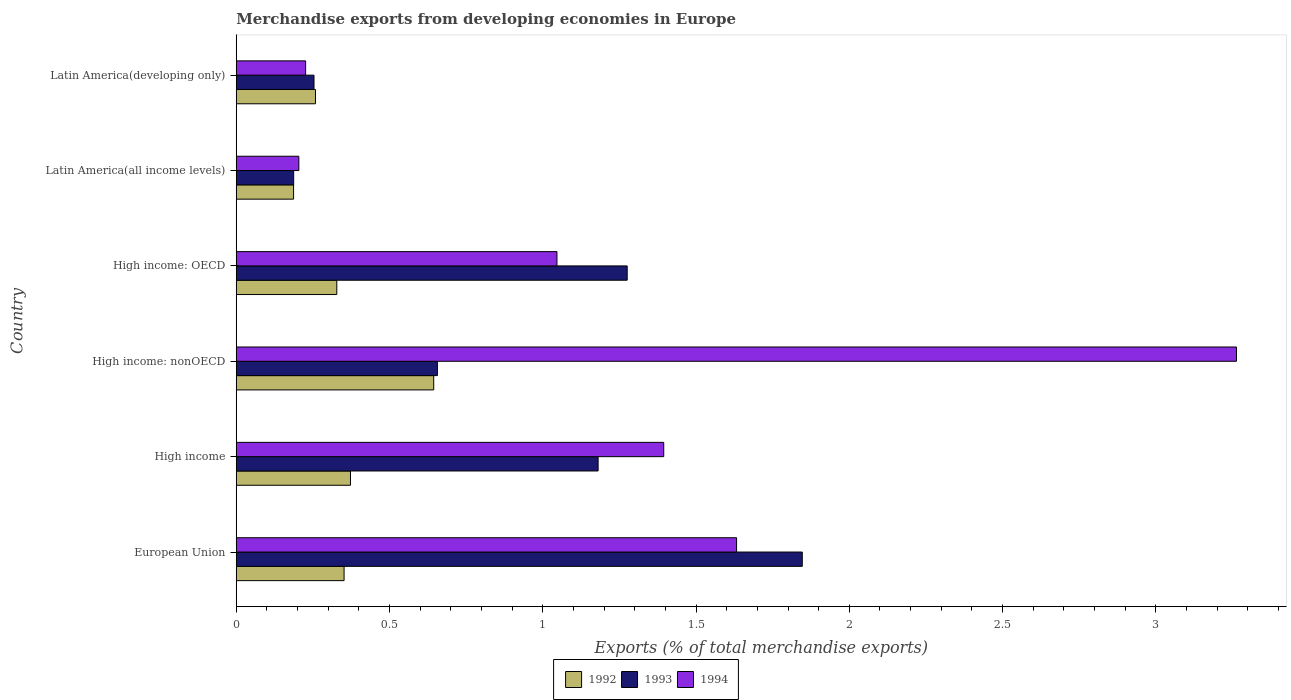How many different coloured bars are there?
Make the answer very short. 3. Are the number of bars per tick equal to the number of legend labels?
Offer a very short reply. Yes. How many bars are there on the 3rd tick from the bottom?
Ensure brevity in your answer.  3. What is the label of the 1st group of bars from the top?
Provide a short and direct response. Latin America(developing only). In how many cases, is the number of bars for a given country not equal to the number of legend labels?
Your answer should be compact. 0. What is the percentage of total merchandise exports in 1993 in High income: nonOECD?
Provide a succinct answer. 0.66. Across all countries, what is the maximum percentage of total merchandise exports in 1993?
Your answer should be compact. 1.85. Across all countries, what is the minimum percentage of total merchandise exports in 1994?
Your answer should be compact. 0.2. In which country was the percentage of total merchandise exports in 1994 maximum?
Ensure brevity in your answer.  High income: nonOECD. In which country was the percentage of total merchandise exports in 1993 minimum?
Your answer should be very brief. Latin America(all income levels). What is the total percentage of total merchandise exports in 1993 in the graph?
Offer a terse response. 5.4. What is the difference between the percentage of total merchandise exports in 1994 in High income: nonOECD and that in Latin America(developing only)?
Give a very brief answer. 3.04. What is the difference between the percentage of total merchandise exports in 1993 in European Union and the percentage of total merchandise exports in 1992 in Latin America(developing only)?
Ensure brevity in your answer.  1.59. What is the average percentage of total merchandise exports in 1994 per country?
Give a very brief answer. 1.29. What is the difference between the percentage of total merchandise exports in 1992 and percentage of total merchandise exports in 1993 in Latin America(all income levels)?
Offer a very short reply. -0. In how many countries, is the percentage of total merchandise exports in 1994 greater than 1.7 %?
Make the answer very short. 1. What is the ratio of the percentage of total merchandise exports in 1992 in European Union to that in Latin America(developing only)?
Your answer should be very brief. 1.36. Is the percentage of total merchandise exports in 1992 in High income: nonOECD less than that in Latin America(developing only)?
Offer a terse response. No. Is the difference between the percentage of total merchandise exports in 1992 in Latin America(all income levels) and Latin America(developing only) greater than the difference between the percentage of total merchandise exports in 1993 in Latin America(all income levels) and Latin America(developing only)?
Keep it short and to the point. No. What is the difference between the highest and the second highest percentage of total merchandise exports in 1992?
Your answer should be compact. 0.27. What is the difference between the highest and the lowest percentage of total merchandise exports in 1993?
Your response must be concise. 1.66. What does the 3rd bar from the top in High income represents?
Your answer should be very brief. 1992. What does the 3rd bar from the bottom in High income represents?
Your answer should be very brief. 1994. How many bars are there?
Offer a very short reply. 18. Are all the bars in the graph horizontal?
Keep it short and to the point. Yes. How many countries are there in the graph?
Your answer should be compact. 6. What is the difference between two consecutive major ticks on the X-axis?
Provide a short and direct response. 0.5. Does the graph contain any zero values?
Offer a terse response. No. How many legend labels are there?
Offer a very short reply. 3. How are the legend labels stacked?
Give a very brief answer. Horizontal. What is the title of the graph?
Your answer should be compact. Merchandise exports from developing economies in Europe. What is the label or title of the X-axis?
Provide a succinct answer. Exports (% of total merchandise exports). What is the label or title of the Y-axis?
Ensure brevity in your answer.  Country. What is the Exports (% of total merchandise exports) of 1992 in European Union?
Provide a short and direct response. 0.35. What is the Exports (% of total merchandise exports) in 1993 in European Union?
Your answer should be very brief. 1.85. What is the Exports (% of total merchandise exports) of 1994 in European Union?
Provide a succinct answer. 1.63. What is the Exports (% of total merchandise exports) of 1992 in High income?
Your answer should be very brief. 0.37. What is the Exports (% of total merchandise exports) of 1993 in High income?
Provide a short and direct response. 1.18. What is the Exports (% of total merchandise exports) of 1994 in High income?
Your answer should be very brief. 1.39. What is the Exports (% of total merchandise exports) of 1992 in High income: nonOECD?
Your answer should be very brief. 0.64. What is the Exports (% of total merchandise exports) of 1993 in High income: nonOECD?
Provide a succinct answer. 0.66. What is the Exports (% of total merchandise exports) in 1994 in High income: nonOECD?
Ensure brevity in your answer.  3.26. What is the Exports (% of total merchandise exports) in 1992 in High income: OECD?
Give a very brief answer. 0.33. What is the Exports (% of total merchandise exports) in 1993 in High income: OECD?
Keep it short and to the point. 1.28. What is the Exports (% of total merchandise exports) of 1994 in High income: OECD?
Offer a very short reply. 1.05. What is the Exports (% of total merchandise exports) of 1992 in Latin America(all income levels)?
Provide a short and direct response. 0.19. What is the Exports (% of total merchandise exports) of 1993 in Latin America(all income levels)?
Your response must be concise. 0.19. What is the Exports (% of total merchandise exports) in 1994 in Latin America(all income levels)?
Offer a terse response. 0.2. What is the Exports (% of total merchandise exports) of 1992 in Latin America(developing only)?
Your answer should be very brief. 0.26. What is the Exports (% of total merchandise exports) in 1993 in Latin America(developing only)?
Keep it short and to the point. 0.25. What is the Exports (% of total merchandise exports) of 1994 in Latin America(developing only)?
Provide a short and direct response. 0.23. Across all countries, what is the maximum Exports (% of total merchandise exports) in 1992?
Offer a terse response. 0.64. Across all countries, what is the maximum Exports (% of total merchandise exports) in 1993?
Offer a terse response. 1.85. Across all countries, what is the maximum Exports (% of total merchandise exports) in 1994?
Keep it short and to the point. 3.26. Across all countries, what is the minimum Exports (% of total merchandise exports) of 1992?
Provide a succinct answer. 0.19. Across all countries, what is the minimum Exports (% of total merchandise exports) in 1993?
Ensure brevity in your answer.  0.19. Across all countries, what is the minimum Exports (% of total merchandise exports) in 1994?
Make the answer very short. 0.2. What is the total Exports (% of total merchandise exports) of 1992 in the graph?
Your response must be concise. 2.14. What is the total Exports (% of total merchandise exports) in 1993 in the graph?
Give a very brief answer. 5.4. What is the total Exports (% of total merchandise exports) in 1994 in the graph?
Keep it short and to the point. 7.77. What is the difference between the Exports (% of total merchandise exports) in 1992 in European Union and that in High income?
Your answer should be compact. -0.02. What is the difference between the Exports (% of total merchandise exports) in 1993 in European Union and that in High income?
Your answer should be very brief. 0.67. What is the difference between the Exports (% of total merchandise exports) in 1994 in European Union and that in High income?
Keep it short and to the point. 0.24. What is the difference between the Exports (% of total merchandise exports) in 1992 in European Union and that in High income: nonOECD?
Your response must be concise. -0.29. What is the difference between the Exports (% of total merchandise exports) of 1993 in European Union and that in High income: nonOECD?
Offer a very short reply. 1.19. What is the difference between the Exports (% of total merchandise exports) of 1994 in European Union and that in High income: nonOECD?
Provide a succinct answer. -1.63. What is the difference between the Exports (% of total merchandise exports) of 1992 in European Union and that in High income: OECD?
Provide a succinct answer. 0.02. What is the difference between the Exports (% of total merchandise exports) in 1993 in European Union and that in High income: OECD?
Keep it short and to the point. 0.57. What is the difference between the Exports (% of total merchandise exports) of 1994 in European Union and that in High income: OECD?
Keep it short and to the point. 0.59. What is the difference between the Exports (% of total merchandise exports) in 1992 in European Union and that in Latin America(all income levels)?
Provide a short and direct response. 0.16. What is the difference between the Exports (% of total merchandise exports) in 1993 in European Union and that in Latin America(all income levels)?
Provide a short and direct response. 1.66. What is the difference between the Exports (% of total merchandise exports) in 1994 in European Union and that in Latin America(all income levels)?
Your answer should be compact. 1.43. What is the difference between the Exports (% of total merchandise exports) of 1992 in European Union and that in Latin America(developing only)?
Offer a very short reply. 0.09. What is the difference between the Exports (% of total merchandise exports) in 1993 in European Union and that in Latin America(developing only)?
Your answer should be very brief. 1.59. What is the difference between the Exports (% of total merchandise exports) in 1994 in European Union and that in Latin America(developing only)?
Give a very brief answer. 1.41. What is the difference between the Exports (% of total merchandise exports) in 1992 in High income and that in High income: nonOECD?
Provide a succinct answer. -0.27. What is the difference between the Exports (% of total merchandise exports) of 1993 in High income and that in High income: nonOECD?
Provide a short and direct response. 0.52. What is the difference between the Exports (% of total merchandise exports) in 1994 in High income and that in High income: nonOECD?
Offer a very short reply. -1.87. What is the difference between the Exports (% of total merchandise exports) in 1992 in High income and that in High income: OECD?
Offer a terse response. 0.04. What is the difference between the Exports (% of total merchandise exports) of 1993 in High income and that in High income: OECD?
Provide a short and direct response. -0.09. What is the difference between the Exports (% of total merchandise exports) of 1994 in High income and that in High income: OECD?
Your answer should be compact. 0.35. What is the difference between the Exports (% of total merchandise exports) in 1992 in High income and that in Latin America(all income levels)?
Offer a very short reply. 0.19. What is the difference between the Exports (% of total merchandise exports) of 1994 in High income and that in Latin America(all income levels)?
Give a very brief answer. 1.19. What is the difference between the Exports (% of total merchandise exports) of 1992 in High income and that in Latin America(developing only)?
Keep it short and to the point. 0.11. What is the difference between the Exports (% of total merchandise exports) in 1993 in High income and that in Latin America(developing only)?
Ensure brevity in your answer.  0.93. What is the difference between the Exports (% of total merchandise exports) in 1994 in High income and that in Latin America(developing only)?
Give a very brief answer. 1.17. What is the difference between the Exports (% of total merchandise exports) of 1992 in High income: nonOECD and that in High income: OECD?
Give a very brief answer. 0.32. What is the difference between the Exports (% of total merchandise exports) in 1993 in High income: nonOECD and that in High income: OECD?
Make the answer very short. -0.62. What is the difference between the Exports (% of total merchandise exports) in 1994 in High income: nonOECD and that in High income: OECD?
Offer a terse response. 2.22. What is the difference between the Exports (% of total merchandise exports) of 1992 in High income: nonOECD and that in Latin America(all income levels)?
Offer a very short reply. 0.46. What is the difference between the Exports (% of total merchandise exports) in 1993 in High income: nonOECD and that in Latin America(all income levels)?
Your response must be concise. 0.47. What is the difference between the Exports (% of total merchandise exports) of 1994 in High income: nonOECD and that in Latin America(all income levels)?
Provide a succinct answer. 3.06. What is the difference between the Exports (% of total merchandise exports) of 1992 in High income: nonOECD and that in Latin America(developing only)?
Give a very brief answer. 0.39. What is the difference between the Exports (% of total merchandise exports) in 1993 in High income: nonOECD and that in Latin America(developing only)?
Provide a short and direct response. 0.4. What is the difference between the Exports (% of total merchandise exports) of 1994 in High income: nonOECD and that in Latin America(developing only)?
Your response must be concise. 3.04. What is the difference between the Exports (% of total merchandise exports) of 1992 in High income: OECD and that in Latin America(all income levels)?
Provide a succinct answer. 0.14. What is the difference between the Exports (% of total merchandise exports) of 1993 in High income: OECD and that in Latin America(all income levels)?
Give a very brief answer. 1.09. What is the difference between the Exports (% of total merchandise exports) of 1994 in High income: OECD and that in Latin America(all income levels)?
Make the answer very short. 0.84. What is the difference between the Exports (% of total merchandise exports) of 1992 in High income: OECD and that in Latin America(developing only)?
Offer a terse response. 0.07. What is the difference between the Exports (% of total merchandise exports) in 1993 in High income: OECD and that in Latin America(developing only)?
Your answer should be compact. 1.02. What is the difference between the Exports (% of total merchandise exports) in 1994 in High income: OECD and that in Latin America(developing only)?
Make the answer very short. 0.82. What is the difference between the Exports (% of total merchandise exports) in 1992 in Latin America(all income levels) and that in Latin America(developing only)?
Offer a very short reply. -0.07. What is the difference between the Exports (% of total merchandise exports) in 1993 in Latin America(all income levels) and that in Latin America(developing only)?
Keep it short and to the point. -0.07. What is the difference between the Exports (% of total merchandise exports) in 1994 in Latin America(all income levels) and that in Latin America(developing only)?
Ensure brevity in your answer.  -0.02. What is the difference between the Exports (% of total merchandise exports) in 1992 in European Union and the Exports (% of total merchandise exports) in 1993 in High income?
Make the answer very short. -0.83. What is the difference between the Exports (% of total merchandise exports) in 1992 in European Union and the Exports (% of total merchandise exports) in 1994 in High income?
Provide a short and direct response. -1.04. What is the difference between the Exports (% of total merchandise exports) of 1993 in European Union and the Exports (% of total merchandise exports) of 1994 in High income?
Your answer should be compact. 0.45. What is the difference between the Exports (% of total merchandise exports) of 1992 in European Union and the Exports (% of total merchandise exports) of 1993 in High income: nonOECD?
Your answer should be compact. -0.3. What is the difference between the Exports (% of total merchandise exports) of 1992 in European Union and the Exports (% of total merchandise exports) of 1994 in High income: nonOECD?
Ensure brevity in your answer.  -2.91. What is the difference between the Exports (% of total merchandise exports) of 1993 in European Union and the Exports (% of total merchandise exports) of 1994 in High income: nonOECD?
Provide a short and direct response. -1.42. What is the difference between the Exports (% of total merchandise exports) in 1992 in European Union and the Exports (% of total merchandise exports) in 1993 in High income: OECD?
Your response must be concise. -0.92. What is the difference between the Exports (% of total merchandise exports) in 1992 in European Union and the Exports (% of total merchandise exports) in 1994 in High income: OECD?
Your response must be concise. -0.69. What is the difference between the Exports (% of total merchandise exports) of 1993 in European Union and the Exports (% of total merchandise exports) of 1994 in High income: OECD?
Give a very brief answer. 0.8. What is the difference between the Exports (% of total merchandise exports) of 1992 in European Union and the Exports (% of total merchandise exports) of 1993 in Latin America(all income levels)?
Your answer should be very brief. 0.16. What is the difference between the Exports (% of total merchandise exports) in 1992 in European Union and the Exports (% of total merchandise exports) in 1994 in Latin America(all income levels)?
Your answer should be compact. 0.15. What is the difference between the Exports (% of total merchandise exports) of 1993 in European Union and the Exports (% of total merchandise exports) of 1994 in Latin America(all income levels)?
Offer a very short reply. 1.64. What is the difference between the Exports (% of total merchandise exports) of 1992 in European Union and the Exports (% of total merchandise exports) of 1993 in Latin America(developing only)?
Keep it short and to the point. 0.1. What is the difference between the Exports (% of total merchandise exports) in 1992 in European Union and the Exports (% of total merchandise exports) in 1994 in Latin America(developing only)?
Provide a short and direct response. 0.13. What is the difference between the Exports (% of total merchandise exports) in 1993 in European Union and the Exports (% of total merchandise exports) in 1994 in Latin America(developing only)?
Ensure brevity in your answer.  1.62. What is the difference between the Exports (% of total merchandise exports) of 1992 in High income and the Exports (% of total merchandise exports) of 1993 in High income: nonOECD?
Keep it short and to the point. -0.28. What is the difference between the Exports (% of total merchandise exports) in 1992 in High income and the Exports (% of total merchandise exports) in 1994 in High income: nonOECD?
Make the answer very short. -2.89. What is the difference between the Exports (% of total merchandise exports) in 1993 in High income and the Exports (% of total merchandise exports) in 1994 in High income: nonOECD?
Give a very brief answer. -2.08. What is the difference between the Exports (% of total merchandise exports) in 1992 in High income and the Exports (% of total merchandise exports) in 1993 in High income: OECD?
Your answer should be compact. -0.9. What is the difference between the Exports (% of total merchandise exports) of 1992 in High income and the Exports (% of total merchandise exports) of 1994 in High income: OECD?
Provide a succinct answer. -0.67. What is the difference between the Exports (% of total merchandise exports) of 1993 in High income and the Exports (% of total merchandise exports) of 1994 in High income: OECD?
Make the answer very short. 0.13. What is the difference between the Exports (% of total merchandise exports) of 1992 in High income and the Exports (% of total merchandise exports) of 1993 in Latin America(all income levels)?
Your answer should be compact. 0.19. What is the difference between the Exports (% of total merchandise exports) in 1992 in High income and the Exports (% of total merchandise exports) in 1994 in Latin America(all income levels)?
Offer a very short reply. 0.17. What is the difference between the Exports (% of total merchandise exports) of 1993 in High income and the Exports (% of total merchandise exports) of 1994 in Latin America(all income levels)?
Your response must be concise. 0.98. What is the difference between the Exports (% of total merchandise exports) in 1992 in High income and the Exports (% of total merchandise exports) in 1993 in Latin America(developing only)?
Your response must be concise. 0.12. What is the difference between the Exports (% of total merchandise exports) in 1992 in High income and the Exports (% of total merchandise exports) in 1994 in Latin America(developing only)?
Your answer should be compact. 0.15. What is the difference between the Exports (% of total merchandise exports) in 1993 in High income and the Exports (% of total merchandise exports) in 1994 in Latin America(developing only)?
Make the answer very short. 0.95. What is the difference between the Exports (% of total merchandise exports) in 1992 in High income: nonOECD and the Exports (% of total merchandise exports) in 1993 in High income: OECD?
Offer a terse response. -0.63. What is the difference between the Exports (% of total merchandise exports) in 1992 in High income: nonOECD and the Exports (% of total merchandise exports) in 1994 in High income: OECD?
Provide a short and direct response. -0.4. What is the difference between the Exports (% of total merchandise exports) of 1993 in High income: nonOECD and the Exports (% of total merchandise exports) of 1994 in High income: OECD?
Your answer should be compact. -0.39. What is the difference between the Exports (% of total merchandise exports) in 1992 in High income: nonOECD and the Exports (% of total merchandise exports) in 1993 in Latin America(all income levels)?
Provide a succinct answer. 0.46. What is the difference between the Exports (% of total merchandise exports) of 1992 in High income: nonOECD and the Exports (% of total merchandise exports) of 1994 in Latin America(all income levels)?
Your answer should be very brief. 0.44. What is the difference between the Exports (% of total merchandise exports) of 1993 in High income: nonOECD and the Exports (% of total merchandise exports) of 1994 in Latin America(all income levels)?
Provide a succinct answer. 0.45. What is the difference between the Exports (% of total merchandise exports) of 1992 in High income: nonOECD and the Exports (% of total merchandise exports) of 1993 in Latin America(developing only)?
Keep it short and to the point. 0.39. What is the difference between the Exports (% of total merchandise exports) in 1992 in High income: nonOECD and the Exports (% of total merchandise exports) in 1994 in Latin America(developing only)?
Your answer should be very brief. 0.42. What is the difference between the Exports (% of total merchandise exports) of 1993 in High income: nonOECD and the Exports (% of total merchandise exports) of 1994 in Latin America(developing only)?
Your answer should be compact. 0.43. What is the difference between the Exports (% of total merchandise exports) in 1992 in High income: OECD and the Exports (% of total merchandise exports) in 1993 in Latin America(all income levels)?
Keep it short and to the point. 0.14. What is the difference between the Exports (% of total merchandise exports) of 1992 in High income: OECD and the Exports (% of total merchandise exports) of 1994 in Latin America(all income levels)?
Make the answer very short. 0.12. What is the difference between the Exports (% of total merchandise exports) of 1993 in High income: OECD and the Exports (% of total merchandise exports) of 1994 in Latin America(all income levels)?
Offer a terse response. 1.07. What is the difference between the Exports (% of total merchandise exports) of 1992 in High income: OECD and the Exports (% of total merchandise exports) of 1993 in Latin America(developing only)?
Provide a succinct answer. 0.07. What is the difference between the Exports (% of total merchandise exports) in 1992 in High income: OECD and the Exports (% of total merchandise exports) in 1994 in Latin America(developing only)?
Keep it short and to the point. 0.1. What is the difference between the Exports (% of total merchandise exports) of 1993 in High income: OECD and the Exports (% of total merchandise exports) of 1994 in Latin America(developing only)?
Offer a very short reply. 1.05. What is the difference between the Exports (% of total merchandise exports) of 1992 in Latin America(all income levels) and the Exports (% of total merchandise exports) of 1993 in Latin America(developing only)?
Ensure brevity in your answer.  -0.07. What is the difference between the Exports (% of total merchandise exports) of 1992 in Latin America(all income levels) and the Exports (% of total merchandise exports) of 1994 in Latin America(developing only)?
Ensure brevity in your answer.  -0.04. What is the difference between the Exports (% of total merchandise exports) in 1993 in Latin America(all income levels) and the Exports (% of total merchandise exports) in 1994 in Latin America(developing only)?
Your answer should be very brief. -0.04. What is the average Exports (% of total merchandise exports) in 1992 per country?
Ensure brevity in your answer.  0.36. What is the average Exports (% of total merchandise exports) of 1993 per country?
Your answer should be very brief. 0.9. What is the average Exports (% of total merchandise exports) of 1994 per country?
Your response must be concise. 1.29. What is the difference between the Exports (% of total merchandise exports) of 1992 and Exports (% of total merchandise exports) of 1993 in European Union?
Your response must be concise. -1.49. What is the difference between the Exports (% of total merchandise exports) of 1992 and Exports (% of total merchandise exports) of 1994 in European Union?
Keep it short and to the point. -1.28. What is the difference between the Exports (% of total merchandise exports) of 1993 and Exports (% of total merchandise exports) of 1994 in European Union?
Your response must be concise. 0.21. What is the difference between the Exports (% of total merchandise exports) of 1992 and Exports (% of total merchandise exports) of 1993 in High income?
Offer a terse response. -0.81. What is the difference between the Exports (% of total merchandise exports) of 1992 and Exports (% of total merchandise exports) of 1994 in High income?
Make the answer very short. -1.02. What is the difference between the Exports (% of total merchandise exports) of 1993 and Exports (% of total merchandise exports) of 1994 in High income?
Provide a short and direct response. -0.21. What is the difference between the Exports (% of total merchandise exports) in 1992 and Exports (% of total merchandise exports) in 1993 in High income: nonOECD?
Offer a terse response. -0.01. What is the difference between the Exports (% of total merchandise exports) in 1992 and Exports (% of total merchandise exports) in 1994 in High income: nonOECD?
Ensure brevity in your answer.  -2.62. What is the difference between the Exports (% of total merchandise exports) of 1993 and Exports (% of total merchandise exports) of 1994 in High income: nonOECD?
Offer a terse response. -2.61. What is the difference between the Exports (% of total merchandise exports) in 1992 and Exports (% of total merchandise exports) in 1993 in High income: OECD?
Your answer should be compact. -0.95. What is the difference between the Exports (% of total merchandise exports) of 1992 and Exports (% of total merchandise exports) of 1994 in High income: OECD?
Offer a terse response. -0.72. What is the difference between the Exports (% of total merchandise exports) of 1993 and Exports (% of total merchandise exports) of 1994 in High income: OECD?
Offer a terse response. 0.23. What is the difference between the Exports (% of total merchandise exports) in 1992 and Exports (% of total merchandise exports) in 1993 in Latin America(all income levels)?
Provide a short and direct response. -0. What is the difference between the Exports (% of total merchandise exports) of 1992 and Exports (% of total merchandise exports) of 1994 in Latin America(all income levels)?
Keep it short and to the point. -0.02. What is the difference between the Exports (% of total merchandise exports) of 1993 and Exports (% of total merchandise exports) of 1994 in Latin America(all income levels)?
Provide a succinct answer. -0.02. What is the difference between the Exports (% of total merchandise exports) of 1992 and Exports (% of total merchandise exports) of 1993 in Latin America(developing only)?
Offer a terse response. 0. What is the difference between the Exports (% of total merchandise exports) of 1992 and Exports (% of total merchandise exports) of 1994 in Latin America(developing only)?
Keep it short and to the point. 0.03. What is the difference between the Exports (% of total merchandise exports) in 1993 and Exports (% of total merchandise exports) in 1994 in Latin America(developing only)?
Provide a short and direct response. 0.03. What is the ratio of the Exports (% of total merchandise exports) of 1992 in European Union to that in High income?
Give a very brief answer. 0.94. What is the ratio of the Exports (% of total merchandise exports) in 1993 in European Union to that in High income?
Make the answer very short. 1.56. What is the ratio of the Exports (% of total merchandise exports) in 1994 in European Union to that in High income?
Your answer should be compact. 1.17. What is the ratio of the Exports (% of total merchandise exports) of 1992 in European Union to that in High income: nonOECD?
Offer a terse response. 0.55. What is the ratio of the Exports (% of total merchandise exports) in 1993 in European Union to that in High income: nonOECD?
Your answer should be very brief. 2.81. What is the ratio of the Exports (% of total merchandise exports) of 1994 in European Union to that in High income: nonOECD?
Provide a short and direct response. 0.5. What is the ratio of the Exports (% of total merchandise exports) of 1992 in European Union to that in High income: OECD?
Make the answer very short. 1.07. What is the ratio of the Exports (% of total merchandise exports) in 1993 in European Union to that in High income: OECD?
Your response must be concise. 1.45. What is the ratio of the Exports (% of total merchandise exports) of 1994 in European Union to that in High income: OECD?
Keep it short and to the point. 1.56. What is the ratio of the Exports (% of total merchandise exports) in 1992 in European Union to that in Latin America(all income levels)?
Your answer should be compact. 1.88. What is the ratio of the Exports (% of total merchandise exports) of 1993 in European Union to that in Latin America(all income levels)?
Provide a succinct answer. 9.86. What is the ratio of the Exports (% of total merchandise exports) of 1994 in European Union to that in Latin America(all income levels)?
Give a very brief answer. 7.99. What is the ratio of the Exports (% of total merchandise exports) of 1992 in European Union to that in Latin America(developing only)?
Provide a short and direct response. 1.36. What is the ratio of the Exports (% of total merchandise exports) of 1993 in European Union to that in Latin America(developing only)?
Provide a short and direct response. 7.28. What is the ratio of the Exports (% of total merchandise exports) of 1994 in European Union to that in Latin America(developing only)?
Offer a terse response. 7.21. What is the ratio of the Exports (% of total merchandise exports) of 1992 in High income to that in High income: nonOECD?
Give a very brief answer. 0.58. What is the ratio of the Exports (% of total merchandise exports) of 1993 in High income to that in High income: nonOECD?
Ensure brevity in your answer.  1.8. What is the ratio of the Exports (% of total merchandise exports) in 1994 in High income to that in High income: nonOECD?
Provide a short and direct response. 0.43. What is the ratio of the Exports (% of total merchandise exports) of 1992 in High income to that in High income: OECD?
Your answer should be very brief. 1.14. What is the ratio of the Exports (% of total merchandise exports) of 1993 in High income to that in High income: OECD?
Provide a succinct answer. 0.93. What is the ratio of the Exports (% of total merchandise exports) in 1994 in High income to that in High income: OECD?
Offer a very short reply. 1.33. What is the ratio of the Exports (% of total merchandise exports) in 1992 in High income to that in Latin America(all income levels)?
Your answer should be very brief. 1.99. What is the ratio of the Exports (% of total merchandise exports) of 1993 in High income to that in Latin America(all income levels)?
Offer a very short reply. 6.3. What is the ratio of the Exports (% of total merchandise exports) in 1994 in High income to that in Latin America(all income levels)?
Offer a very short reply. 6.83. What is the ratio of the Exports (% of total merchandise exports) of 1992 in High income to that in Latin America(developing only)?
Make the answer very short. 1.44. What is the ratio of the Exports (% of total merchandise exports) in 1993 in High income to that in Latin America(developing only)?
Ensure brevity in your answer.  4.65. What is the ratio of the Exports (% of total merchandise exports) of 1994 in High income to that in Latin America(developing only)?
Provide a succinct answer. 6.16. What is the ratio of the Exports (% of total merchandise exports) of 1992 in High income: nonOECD to that in High income: OECD?
Keep it short and to the point. 1.96. What is the ratio of the Exports (% of total merchandise exports) in 1993 in High income: nonOECD to that in High income: OECD?
Provide a short and direct response. 0.51. What is the ratio of the Exports (% of total merchandise exports) of 1994 in High income: nonOECD to that in High income: OECD?
Provide a short and direct response. 3.12. What is the ratio of the Exports (% of total merchandise exports) in 1992 in High income: nonOECD to that in Latin America(all income levels)?
Offer a very short reply. 3.44. What is the ratio of the Exports (% of total merchandise exports) of 1993 in High income: nonOECD to that in Latin America(all income levels)?
Ensure brevity in your answer.  3.5. What is the ratio of the Exports (% of total merchandise exports) in 1994 in High income: nonOECD to that in Latin America(all income levels)?
Provide a succinct answer. 15.98. What is the ratio of the Exports (% of total merchandise exports) in 1992 in High income: nonOECD to that in Latin America(developing only)?
Provide a short and direct response. 2.49. What is the ratio of the Exports (% of total merchandise exports) of 1993 in High income: nonOECD to that in Latin America(developing only)?
Keep it short and to the point. 2.59. What is the ratio of the Exports (% of total merchandise exports) of 1994 in High income: nonOECD to that in Latin America(developing only)?
Ensure brevity in your answer.  14.42. What is the ratio of the Exports (% of total merchandise exports) of 1992 in High income: OECD to that in Latin America(all income levels)?
Keep it short and to the point. 1.75. What is the ratio of the Exports (% of total merchandise exports) in 1993 in High income: OECD to that in Latin America(all income levels)?
Provide a succinct answer. 6.81. What is the ratio of the Exports (% of total merchandise exports) of 1994 in High income: OECD to that in Latin America(all income levels)?
Give a very brief answer. 5.12. What is the ratio of the Exports (% of total merchandise exports) of 1992 in High income: OECD to that in Latin America(developing only)?
Keep it short and to the point. 1.27. What is the ratio of the Exports (% of total merchandise exports) in 1993 in High income: OECD to that in Latin America(developing only)?
Your response must be concise. 5.03. What is the ratio of the Exports (% of total merchandise exports) in 1994 in High income: OECD to that in Latin America(developing only)?
Ensure brevity in your answer.  4.62. What is the ratio of the Exports (% of total merchandise exports) in 1992 in Latin America(all income levels) to that in Latin America(developing only)?
Provide a short and direct response. 0.72. What is the ratio of the Exports (% of total merchandise exports) in 1993 in Latin America(all income levels) to that in Latin America(developing only)?
Your answer should be very brief. 0.74. What is the ratio of the Exports (% of total merchandise exports) of 1994 in Latin America(all income levels) to that in Latin America(developing only)?
Offer a terse response. 0.9. What is the difference between the highest and the second highest Exports (% of total merchandise exports) of 1992?
Your answer should be very brief. 0.27. What is the difference between the highest and the second highest Exports (% of total merchandise exports) in 1993?
Keep it short and to the point. 0.57. What is the difference between the highest and the second highest Exports (% of total merchandise exports) in 1994?
Provide a short and direct response. 1.63. What is the difference between the highest and the lowest Exports (% of total merchandise exports) in 1992?
Keep it short and to the point. 0.46. What is the difference between the highest and the lowest Exports (% of total merchandise exports) in 1993?
Provide a succinct answer. 1.66. What is the difference between the highest and the lowest Exports (% of total merchandise exports) of 1994?
Give a very brief answer. 3.06. 